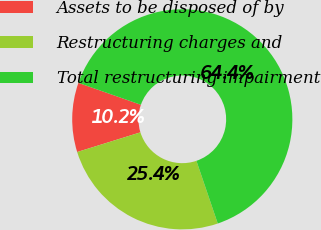Convert chart. <chart><loc_0><loc_0><loc_500><loc_500><pie_chart><fcel>Assets to be disposed of by<fcel>Restructuring charges and<fcel>Total restructuring impairment<nl><fcel>10.17%<fcel>25.42%<fcel>64.41%<nl></chart> 